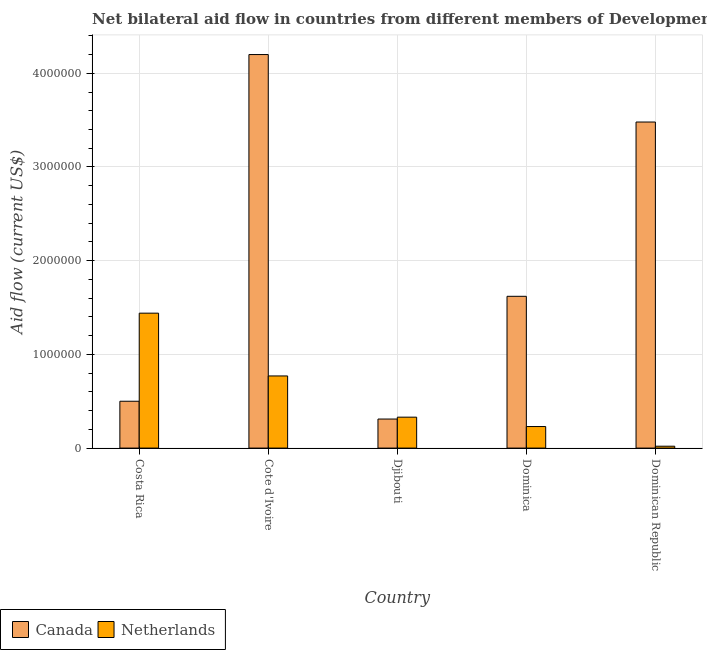Are the number of bars per tick equal to the number of legend labels?
Offer a terse response. Yes. Are the number of bars on each tick of the X-axis equal?
Offer a very short reply. Yes. How many bars are there on the 5th tick from the right?
Your response must be concise. 2. What is the label of the 4th group of bars from the left?
Give a very brief answer. Dominica. In how many cases, is the number of bars for a given country not equal to the number of legend labels?
Offer a very short reply. 0. What is the amount of aid given by canada in Cote d'Ivoire?
Your answer should be very brief. 4.20e+06. Across all countries, what is the maximum amount of aid given by canada?
Your response must be concise. 4.20e+06. Across all countries, what is the minimum amount of aid given by canada?
Keep it short and to the point. 3.10e+05. In which country was the amount of aid given by canada maximum?
Offer a terse response. Cote d'Ivoire. In which country was the amount of aid given by netherlands minimum?
Your answer should be compact. Dominican Republic. What is the total amount of aid given by netherlands in the graph?
Your answer should be compact. 2.79e+06. What is the difference between the amount of aid given by canada in Cote d'Ivoire and that in Dominica?
Your answer should be very brief. 2.58e+06. What is the difference between the amount of aid given by canada in Dominica and the amount of aid given by netherlands in Dominican Republic?
Keep it short and to the point. 1.60e+06. What is the average amount of aid given by canada per country?
Your response must be concise. 2.02e+06. What is the difference between the amount of aid given by canada and amount of aid given by netherlands in Cote d'Ivoire?
Make the answer very short. 3.43e+06. What is the ratio of the amount of aid given by netherlands in Cote d'Ivoire to that in Djibouti?
Offer a very short reply. 2.33. Is the amount of aid given by canada in Costa Rica less than that in Dominican Republic?
Give a very brief answer. Yes. What is the difference between the highest and the second highest amount of aid given by canada?
Offer a very short reply. 7.20e+05. What is the difference between the highest and the lowest amount of aid given by netherlands?
Ensure brevity in your answer.  1.42e+06. Is the sum of the amount of aid given by canada in Djibouti and Dominican Republic greater than the maximum amount of aid given by netherlands across all countries?
Make the answer very short. Yes. What does the 1st bar from the left in Costa Rica represents?
Your answer should be compact. Canada. What does the 2nd bar from the right in Cote d'Ivoire represents?
Your response must be concise. Canada. Are all the bars in the graph horizontal?
Provide a short and direct response. No. How many countries are there in the graph?
Give a very brief answer. 5. What is the difference between two consecutive major ticks on the Y-axis?
Offer a very short reply. 1.00e+06. Does the graph contain grids?
Offer a terse response. Yes. Where does the legend appear in the graph?
Provide a short and direct response. Bottom left. How are the legend labels stacked?
Your answer should be very brief. Horizontal. What is the title of the graph?
Give a very brief answer. Net bilateral aid flow in countries from different members of Development Assistance Committee. Does "Forest land" appear as one of the legend labels in the graph?
Ensure brevity in your answer.  No. What is the Aid flow (current US$) of Netherlands in Costa Rica?
Make the answer very short. 1.44e+06. What is the Aid flow (current US$) of Canada in Cote d'Ivoire?
Keep it short and to the point. 4.20e+06. What is the Aid flow (current US$) in Netherlands in Cote d'Ivoire?
Your response must be concise. 7.70e+05. What is the Aid flow (current US$) of Canada in Djibouti?
Your answer should be very brief. 3.10e+05. What is the Aid flow (current US$) in Canada in Dominica?
Your answer should be very brief. 1.62e+06. What is the Aid flow (current US$) in Canada in Dominican Republic?
Offer a terse response. 3.48e+06. Across all countries, what is the maximum Aid flow (current US$) of Canada?
Offer a very short reply. 4.20e+06. Across all countries, what is the maximum Aid flow (current US$) of Netherlands?
Offer a very short reply. 1.44e+06. What is the total Aid flow (current US$) in Canada in the graph?
Provide a succinct answer. 1.01e+07. What is the total Aid flow (current US$) of Netherlands in the graph?
Make the answer very short. 2.79e+06. What is the difference between the Aid flow (current US$) of Canada in Costa Rica and that in Cote d'Ivoire?
Provide a short and direct response. -3.70e+06. What is the difference between the Aid flow (current US$) of Netherlands in Costa Rica and that in Cote d'Ivoire?
Your response must be concise. 6.70e+05. What is the difference between the Aid flow (current US$) of Canada in Costa Rica and that in Djibouti?
Your answer should be very brief. 1.90e+05. What is the difference between the Aid flow (current US$) of Netherlands in Costa Rica and that in Djibouti?
Give a very brief answer. 1.11e+06. What is the difference between the Aid flow (current US$) in Canada in Costa Rica and that in Dominica?
Keep it short and to the point. -1.12e+06. What is the difference between the Aid flow (current US$) of Netherlands in Costa Rica and that in Dominica?
Ensure brevity in your answer.  1.21e+06. What is the difference between the Aid flow (current US$) in Canada in Costa Rica and that in Dominican Republic?
Offer a very short reply. -2.98e+06. What is the difference between the Aid flow (current US$) in Netherlands in Costa Rica and that in Dominican Republic?
Your answer should be very brief. 1.42e+06. What is the difference between the Aid flow (current US$) in Canada in Cote d'Ivoire and that in Djibouti?
Offer a very short reply. 3.89e+06. What is the difference between the Aid flow (current US$) of Netherlands in Cote d'Ivoire and that in Djibouti?
Offer a very short reply. 4.40e+05. What is the difference between the Aid flow (current US$) of Canada in Cote d'Ivoire and that in Dominica?
Keep it short and to the point. 2.58e+06. What is the difference between the Aid flow (current US$) in Netherlands in Cote d'Ivoire and that in Dominica?
Give a very brief answer. 5.40e+05. What is the difference between the Aid flow (current US$) in Canada in Cote d'Ivoire and that in Dominican Republic?
Your answer should be compact. 7.20e+05. What is the difference between the Aid flow (current US$) in Netherlands in Cote d'Ivoire and that in Dominican Republic?
Provide a short and direct response. 7.50e+05. What is the difference between the Aid flow (current US$) of Canada in Djibouti and that in Dominica?
Provide a short and direct response. -1.31e+06. What is the difference between the Aid flow (current US$) in Netherlands in Djibouti and that in Dominica?
Keep it short and to the point. 1.00e+05. What is the difference between the Aid flow (current US$) of Canada in Djibouti and that in Dominican Republic?
Offer a terse response. -3.17e+06. What is the difference between the Aid flow (current US$) of Canada in Dominica and that in Dominican Republic?
Your answer should be very brief. -1.86e+06. What is the difference between the Aid flow (current US$) in Canada in Costa Rica and the Aid flow (current US$) in Netherlands in Dominica?
Make the answer very short. 2.70e+05. What is the difference between the Aid flow (current US$) of Canada in Costa Rica and the Aid flow (current US$) of Netherlands in Dominican Republic?
Your response must be concise. 4.80e+05. What is the difference between the Aid flow (current US$) of Canada in Cote d'Ivoire and the Aid flow (current US$) of Netherlands in Djibouti?
Provide a short and direct response. 3.87e+06. What is the difference between the Aid flow (current US$) of Canada in Cote d'Ivoire and the Aid flow (current US$) of Netherlands in Dominica?
Give a very brief answer. 3.97e+06. What is the difference between the Aid flow (current US$) of Canada in Cote d'Ivoire and the Aid flow (current US$) of Netherlands in Dominican Republic?
Keep it short and to the point. 4.18e+06. What is the difference between the Aid flow (current US$) in Canada in Djibouti and the Aid flow (current US$) in Netherlands in Dominica?
Offer a very short reply. 8.00e+04. What is the difference between the Aid flow (current US$) of Canada in Djibouti and the Aid flow (current US$) of Netherlands in Dominican Republic?
Your response must be concise. 2.90e+05. What is the difference between the Aid flow (current US$) in Canada in Dominica and the Aid flow (current US$) in Netherlands in Dominican Republic?
Give a very brief answer. 1.60e+06. What is the average Aid flow (current US$) of Canada per country?
Offer a very short reply. 2.02e+06. What is the average Aid flow (current US$) in Netherlands per country?
Provide a succinct answer. 5.58e+05. What is the difference between the Aid flow (current US$) of Canada and Aid flow (current US$) of Netherlands in Costa Rica?
Ensure brevity in your answer.  -9.40e+05. What is the difference between the Aid flow (current US$) of Canada and Aid flow (current US$) of Netherlands in Cote d'Ivoire?
Provide a succinct answer. 3.43e+06. What is the difference between the Aid flow (current US$) of Canada and Aid flow (current US$) of Netherlands in Dominica?
Provide a succinct answer. 1.39e+06. What is the difference between the Aid flow (current US$) in Canada and Aid flow (current US$) in Netherlands in Dominican Republic?
Ensure brevity in your answer.  3.46e+06. What is the ratio of the Aid flow (current US$) in Canada in Costa Rica to that in Cote d'Ivoire?
Your response must be concise. 0.12. What is the ratio of the Aid flow (current US$) of Netherlands in Costa Rica to that in Cote d'Ivoire?
Offer a terse response. 1.87. What is the ratio of the Aid flow (current US$) of Canada in Costa Rica to that in Djibouti?
Offer a very short reply. 1.61. What is the ratio of the Aid flow (current US$) of Netherlands in Costa Rica to that in Djibouti?
Your answer should be compact. 4.36. What is the ratio of the Aid flow (current US$) in Canada in Costa Rica to that in Dominica?
Keep it short and to the point. 0.31. What is the ratio of the Aid flow (current US$) in Netherlands in Costa Rica to that in Dominica?
Offer a very short reply. 6.26. What is the ratio of the Aid flow (current US$) in Canada in Costa Rica to that in Dominican Republic?
Offer a terse response. 0.14. What is the ratio of the Aid flow (current US$) of Netherlands in Costa Rica to that in Dominican Republic?
Provide a short and direct response. 72. What is the ratio of the Aid flow (current US$) in Canada in Cote d'Ivoire to that in Djibouti?
Your response must be concise. 13.55. What is the ratio of the Aid flow (current US$) of Netherlands in Cote d'Ivoire to that in Djibouti?
Provide a succinct answer. 2.33. What is the ratio of the Aid flow (current US$) in Canada in Cote d'Ivoire to that in Dominica?
Give a very brief answer. 2.59. What is the ratio of the Aid flow (current US$) in Netherlands in Cote d'Ivoire to that in Dominica?
Your answer should be very brief. 3.35. What is the ratio of the Aid flow (current US$) of Canada in Cote d'Ivoire to that in Dominican Republic?
Ensure brevity in your answer.  1.21. What is the ratio of the Aid flow (current US$) of Netherlands in Cote d'Ivoire to that in Dominican Republic?
Ensure brevity in your answer.  38.5. What is the ratio of the Aid flow (current US$) in Canada in Djibouti to that in Dominica?
Your answer should be very brief. 0.19. What is the ratio of the Aid flow (current US$) in Netherlands in Djibouti to that in Dominica?
Make the answer very short. 1.43. What is the ratio of the Aid flow (current US$) in Canada in Djibouti to that in Dominican Republic?
Offer a very short reply. 0.09. What is the ratio of the Aid flow (current US$) in Canada in Dominica to that in Dominican Republic?
Offer a very short reply. 0.47. What is the difference between the highest and the second highest Aid flow (current US$) of Canada?
Provide a succinct answer. 7.20e+05. What is the difference between the highest and the second highest Aid flow (current US$) of Netherlands?
Give a very brief answer. 6.70e+05. What is the difference between the highest and the lowest Aid flow (current US$) of Canada?
Keep it short and to the point. 3.89e+06. What is the difference between the highest and the lowest Aid flow (current US$) of Netherlands?
Provide a short and direct response. 1.42e+06. 